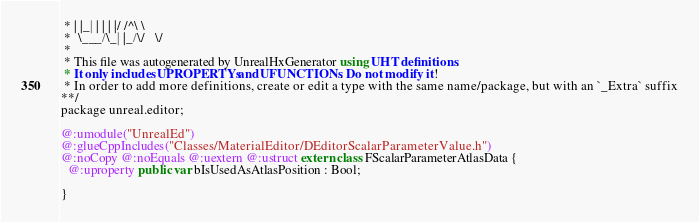Convert code to text. <code><loc_0><loc_0><loc_500><loc_500><_Haxe_> * | |_| | | | |/ /^\ \ 
 *  \___/\_| |_/\/   \/ 
 * 
 * This file was autogenerated by UnrealHxGenerator using UHT definitions.
 * It only includes UPROPERTYs and UFUNCTIONs. Do not modify it!
 * In order to add more definitions, create or edit a type with the same name/package, but with an `_Extra` suffix
**/
package unreal.editor;

@:umodule("UnrealEd")
@:glueCppIncludes("Classes/MaterialEditor/DEditorScalarParameterValue.h")
@:noCopy @:noEquals @:uextern @:ustruct extern class FScalarParameterAtlasData {
  @:uproperty public var bIsUsedAsAtlasPosition : Bool;
  
}
</code> 